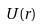<formula> <loc_0><loc_0><loc_500><loc_500>U ( r )</formula> 